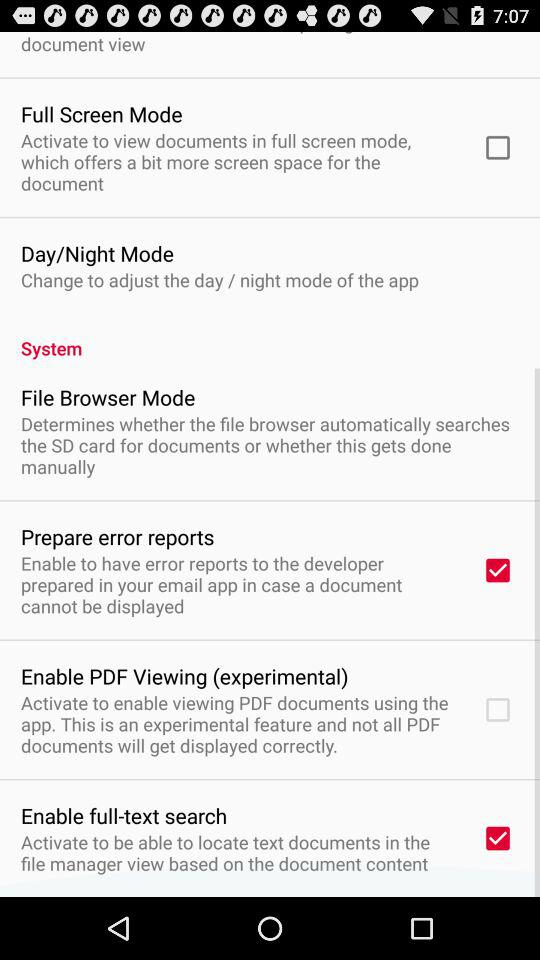What is the status of "Prepare error reports"? The status is on. 